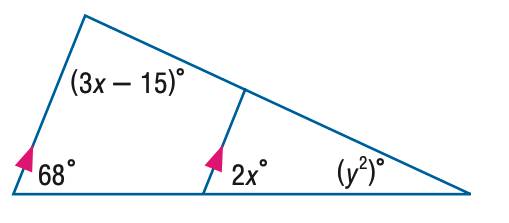Question: Find x in the figure.
Choices:
A. 27.7
B. 34
C. 41.3
D. 68
Answer with the letter. Answer: B 